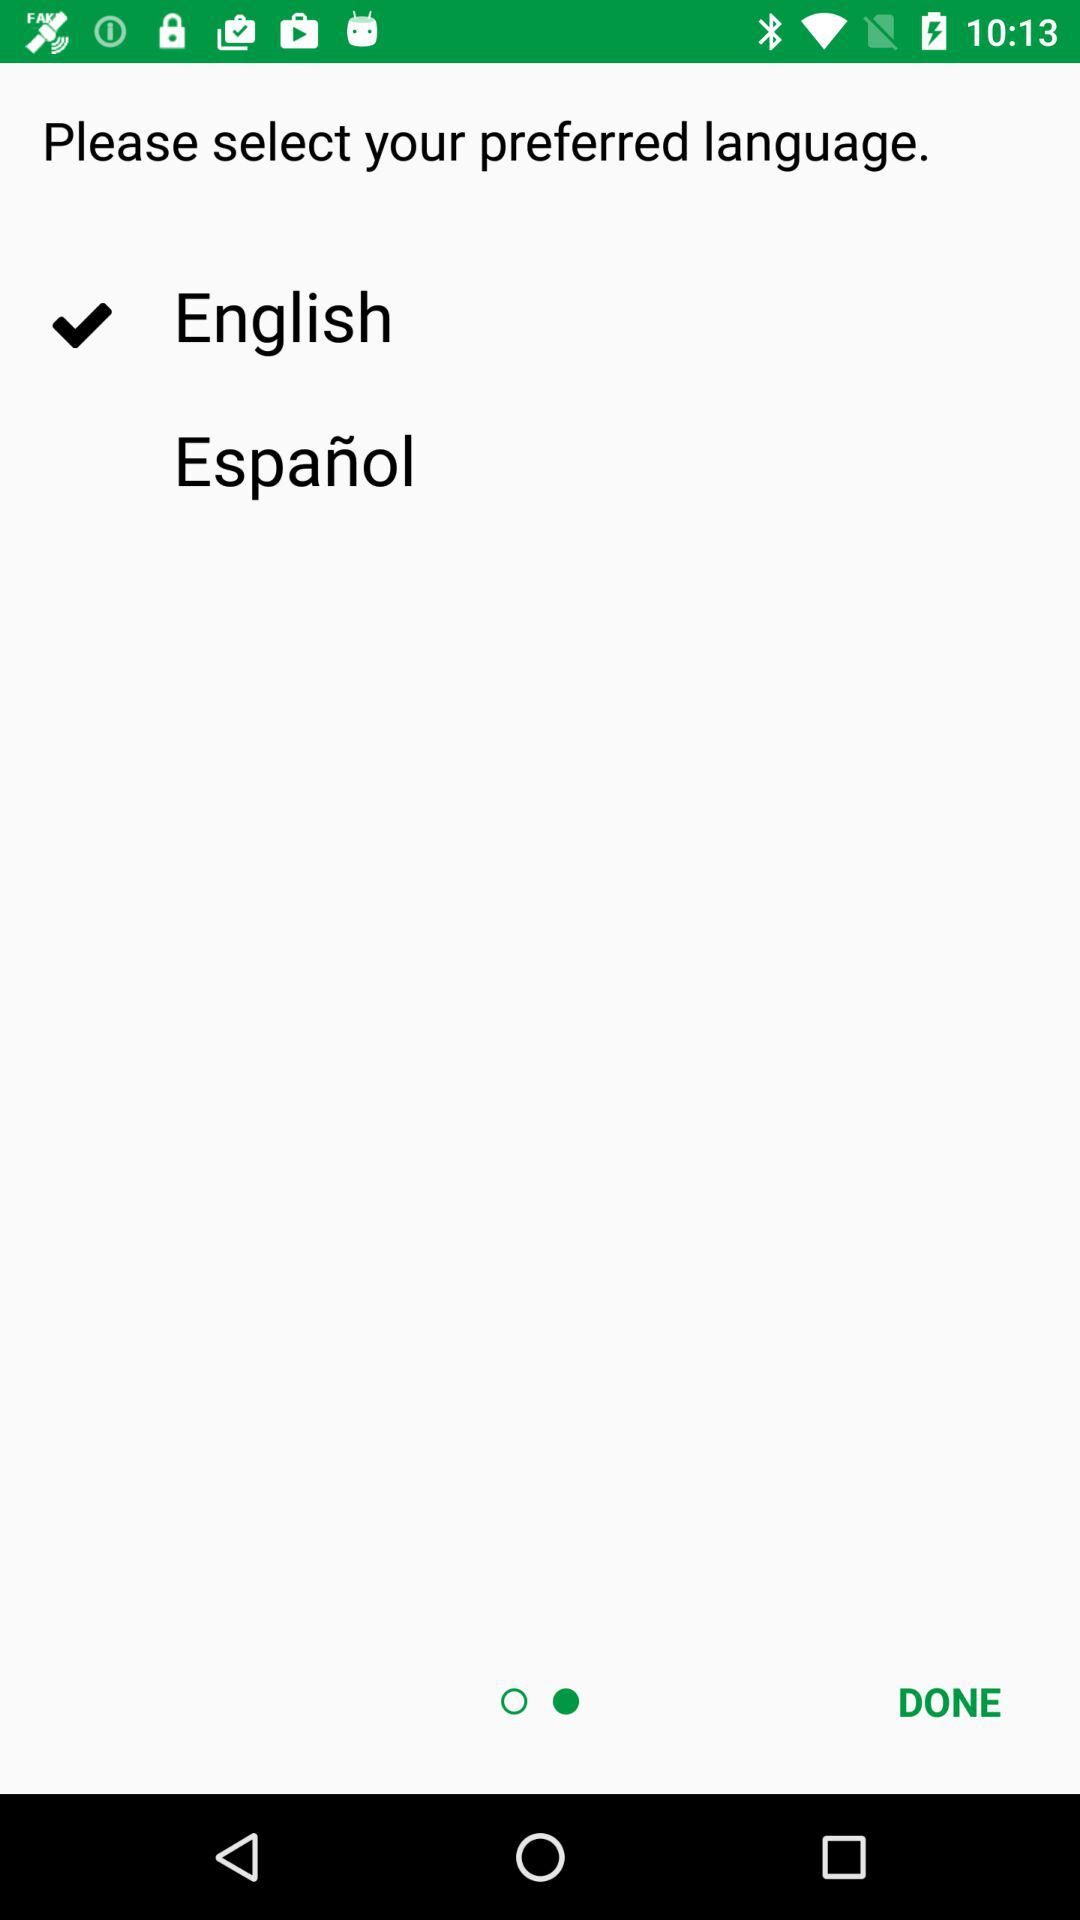What are the languages that I can select as my preferred language? The languages that you can select as your preferred language are English and Español. 